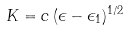<formula> <loc_0><loc_0><loc_500><loc_500>K = c \, ( \epsilon - \epsilon _ { 1 } ) ^ { 1 / 2 }</formula> 